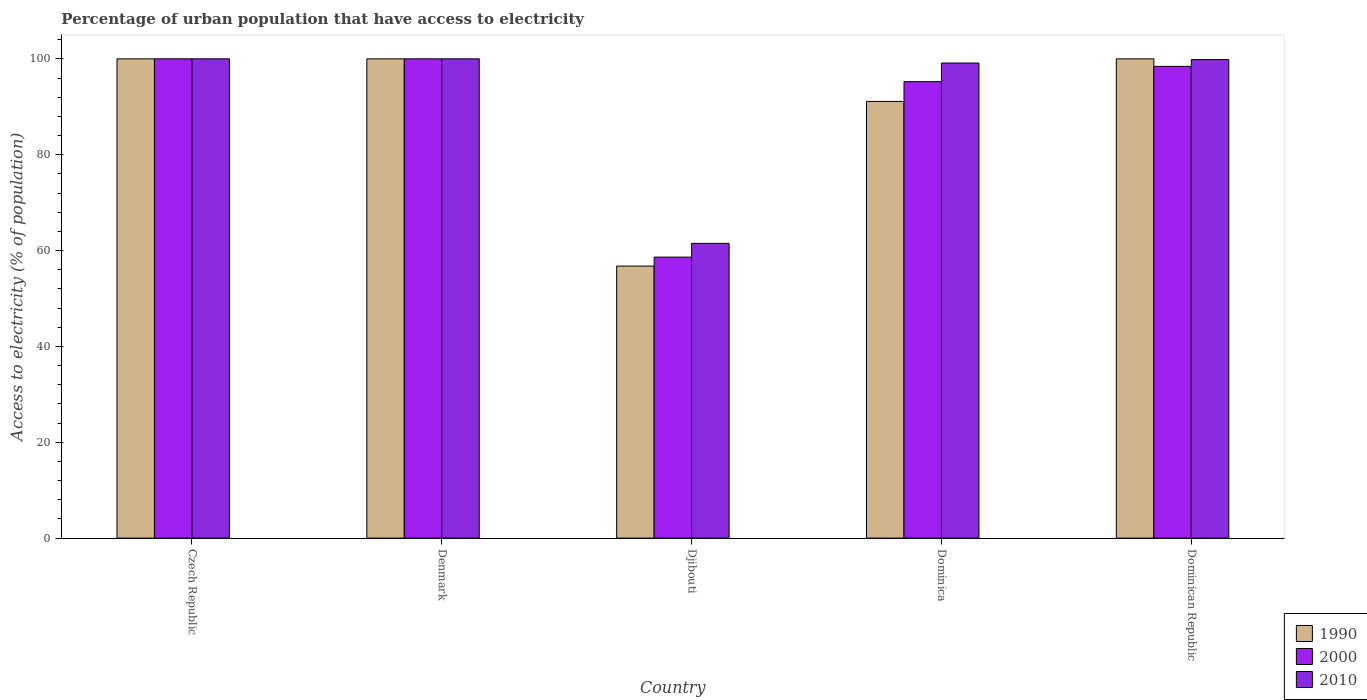How many groups of bars are there?
Provide a short and direct response. 5. Are the number of bars per tick equal to the number of legend labels?
Ensure brevity in your answer.  Yes. Are the number of bars on each tick of the X-axis equal?
Offer a very short reply. Yes. How many bars are there on the 5th tick from the left?
Provide a short and direct response. 3. What is the label of the 1st group of bars from the left?
Provide a succinct answer. Czech Republic. In how many cases, is the number of bars for a given country not equal to the number of legend labels?
Ensure brevity in your answer.  0. Across all countries, what is the minimum percentage of urban population that have access to electricity in 2000?
Offer a very short reply. 58.63. In which country was the percentage of urban population that have access to electricity in 2010 maximum?
Your response must be concise. Czech Republic. In which country was the percentage of urban population that have access to electricity in 1990 minimum?
Give a very brief answer. Djibouti. What is the total percentage of urban population that have access to electricity in 1990 in the graph?
Your response must be concise. 447.87. What is the difference between the percentage of urban population that have access to electricity in 1990 in Denmark and that in Dominica?
Keep it short and to the point. 8.88. What is the difference between the percentage of urban population that have access to electricity in 2000 in Czech Republic and the percentage of urban population that have access to electricity in 1990 in Denmark?
Your answer should be compact. 0. What is the average percentage of urban population that have access to electricity in 2000 per country?
Your answer should be compact. 90.46. What is the difference between the percentage of urban population that have access to electricity of/in 1990 and percentage of urban population that have access to electricity of/in 2010 in Djibouti?
Offer a very short reply. -4.74. In how many countries, is the percentage of urban population that have access to electricity in 2000 greater than 60 %?
Give a very brief answer. 4. What is the ratio of the percentage of urban population that have access to electricity in 1990 in Dominica to that in Dominican Republic?
Your answer should be compact. 0.91. Is the percentage of urban population that have access to electricity in 2010 in Czech Republic less than that in Denmark?
Your response must be concise. No. Is the difference between the percentage of urban population that have access to electricity in 1990 in Djibouti and Dominica greater than the difference between the percentage of urban population that have access to electricity in 2010 in Djibouti and Dominica?
Your response must be concise. Yes. What is the difference between the highest and the second highest percentage of urban population that have access to electricity in 2000?
Keep it short and to the point. -1.57. What is the difference between the highest and the lowest percentage of urban population that have access to electricity in 1990?
Your answer should be compact. 43.24. In how many countries, is the percentage of urban population that have access to electricity in 2010 greater than the average percentage of urban population that have access to electricity in 2010 taken over all countries?
Make the answer very short. 4. Are all the bars in the graph horizontal?
Offer a very short reply. No. What is the difference between two consecutive major ticks on the Y-axis?
Provide a short and direct response. 20. Does the graph contain any zero values?
Provide a short and direct response. No. Does the graph contain grids?
Your answer should be very brief. No. Where does the legend appear in the graph?
Keep it short and to the point. Bottom right. How many legend labels are there?
Offer a very short reply. 3. How are the legend labels stacked?
Make the answer very short. Vertical. What is the title of the graph?
Provide a short and direct response. Percentage of urban population that have access to electricity. What is the label or title of the Y-axis?
Offer a very short reply. Access to electricity (% of population). What is the Access to electricity (% of population) of 1990 in Czech Republic?
Your response must be concise. 100. What is the Access to electricity (% of population) in 1990 in Denmark?
Offer a terse response. 100. What is the Access to electricity (% of population) of 1990 in Djibouti?
Your response must be concise. 56.76. What is the Access to electricity (% of population) of 2000 in Djibouti?
Keep it short and to the point. 58.63. What is the Access to electricity (% of population) of 2010 in Djibouti?
Your answer should be compact. 61.5. What is the Access to electricity (% of population) of 1990 in Dominica?
Offer a terse response. 91.12. What is the Access to electricity (% of population) of 2000 in Dominica?
Provide a short and direct response. 95.24. What is the Access to electricity (% of population) of 2010 in Dominica?
Ensure brevity in your answer.  99.13. What is the Access to electricity (% of population) of 1990 in Dominican Republic?
Your response must be concise. 100. What is the Access to electricity (% of population) in 2000 in Dominican Republic?
Ensure brevity in your answer.  98.43. What is the Access to electricity (% of population) in 2010 in Dominican Republic?
Give a very brief answer. 99.84. Across all countries, what is the maximum Access to electricity (% of population) of 1990?
Ensure brevity in your answer.  100. Across all countries, what is the maximum Access to electricity (% of population) in 2000?
Provide a short and direct response. 100. Across all countries, what is the minimum Access to electricity (% of population) in 1990?
Make the answer very short. 56.76. Across all countries, what is the minimum Access to electricity (% of population) of 2000?
Keep it short and to the point. 58.63. Across all countries, what is the minimum Access to electricity (% of population) in 2010?
Make the answer very short. 61.5. What is the total Access to electricity (% of population) in 1990 in the graph?
Your answer should be very brief. 447.87. What is the total Access to electricity (% of population) of 2000 in the graph?
Your answer should be very brief. 452.3. What is the total Access to electricity (% of population) of 2010 in the graph?
Your answer should be very brief. 460.46. What is the difference between the Access to electricity (% of population) in 1990 in Czech Republic and that in Denmark?
Offer a very short reply. 0. What is the difference between the Access to electricity (% of population) of 2000 in Czech Republic and that in Denmark?
Give a very brief answer. 0. What is the difference between the Access to electricity (% of population) of 2010 in Czech Republic and that in Denmark?
Provide a succinct answer. 0. What is the difference between the Access to electricity (% of population) in 1990 in Czech Republic and that in Djibouti?
Provide a short and direct response. 43.24. What is the difference between the Access to electricity (% of population) of 2000 in Czech Republic and that in Djibouti?
Give a very brief answer. 41.37. What is the difference between the Access to electricity (% of population) of 2010 in Czech Republic and that in Djibouti?
Offer a terse response. 38.5. What is the difference between the Access to electricity (% of population) in 1990 in Czech Republic and that in Dominica?
Your answer should be very brief. 8.88. What is the difference between the Access to electricity (% of population) of 2000 in Czech Republic and that in Dominica?
Offer a terse response. 4.76. What is the difference between the Access to electricity (% of population) in 2010 in Czech Republic and that in Dominica?
Offer a very short reply. 0.87. What is the difference between the Access to electricity (% of population) in 2000 in Czech Republic and that in Dominican Republic?
Keep it short and to the point. 1.57. What is the difference between the Access to electricity (% of population) in 2010 in Czech Republic and that in Dominican Republic?
Offer a very short reply. 0.16. What is the difference between the Access to electricity (% of population) in 1990 in Denmark and that in Djibouti?
Your response must be concise. 43.24. What is the difference between the Access to electricity (% of population) of 2000 in Denmark and that in Djibouti?
Your answer should be very brief. 41.37. What is the difference between the Access to electricity (% of population) in 2010 in Denmark and that in Djibouti?
Give a very brief answer. 38.5. What is the difference between the Access to electricity (% of population) of 1990 in Denmark and that in Dominica?
Provide a succinct answer. 8.88. What is the difference between the Access to electricity (% of population) of 2000 in Denmark and that in Dominica?
Give a very brief answer. 4.76. What is the difference between the Access to electricity (% of population) in 2010 in Denmark and that in Dominica?
Ensure brevity in your answer.  0.87. What is the difference between the Access to electricity (% of population) of 2000 in Denmark and that in Dominican Republic?
Offer a very short reply. 1.57. What is the difference between the Access to electricity (% of population) in 2010 in Denmark and that in Dominican Republic?
Your response must be concise. 0.16. What is the difference between the Access to electricity (% of population) in 1990 in Djibouti and that in Dominica?
Keep it short and to the point. -34.36. What is the difference between the Access to electricity (% of population) of 2000 in Djibouti and that in Dominica?
Give a very brief answer. -36.61. What is the difference between the Access to electricity (% of population) of 2010 in Djibouti and that in Dominica?
Ensure brevity in your answer.  -37.63. What is the difference between the Access to electricity (% of population) in 1990 in Djibouti and that in Dominican Republic?
Give a very brief answer. -43.24. What is the difference between the Access to electricity (% of population) of 2000 in Djibouti and that in Dominican Republic?
Make the answer very short. -39.8. What is the difference between the Access to electricity (% of population) of 2010 in Djibouti and that in Dominican Republic?
Your response must be concise. -38.34. What is the difference between the Access to electricity (% of population) of 1990 in Dominica and that in Dominican Republic?
Provide a succinct answer. -8.88. What is the difference between the Access to electricity (% of population) of 2000 in Dominica and that in Dominican Republic?
Provide a short and direct response. -3.18. What is the difference between the Access to electricity (% of population) of 2010 in Dominica and that in Dominican Republic?
Offer a very short reply. -0.71. What is the difference between the Access to electricity (% of population) of 2000 in Czech Republic and the Access to electricity (% of population) of 2010 in Denmark?
Provide a succinct answer. 0. What is the difference between the Access to electricity (% of population) in 1990 in Czech Republic and the Access to electricity (% of population) in 2000 in Djibouti?
Provide a succinct answer. 41.37. What is the difference between the Access to electricity (% of population) of 1990 in Czech Republic and the Access to electricity (% of population) of 2010 in Djibouti?
Your answer should be very brief. 38.5. What is the difference between the Access to electricity (% of population) in 2000 in Czech Republic and the Access to electricity (% of population) in 2010 in Djibouti?
Your response must be concise. 38.5. What is the difference between the Access to electricity (% of population) in 1990 in Czech Republic and the Access to electricity (% of population) in 2000 in Dominica?
Give a very brief answer. 4.76. What is the difference between the Access to electricity (% of population) in 1990 in Czech Republic and the Access to electricity (% of population) in 2010 in Dominica?
Give a very brief answer. 0.87. What is the difference between the Access to electricity (% of population) of 2000 in Czech Republic and the Access to electricity (% of population) of 2010 in Dominica?
Ensure brevity in your answer.  0.87. What is the difference between the Access to electricity (% of population) of 1990 in Czech Republic and the Access to electricity (% of population) of 2000 in Dominican Republic?
Make the answer very short. 1.57. What is the difference between the Access to electricity (% of population) in 1990 in Czech Republic and the Access to electricity (% of population) in 2010 in Dominican Republic?
Your answer should be compact. 0.16. What is the difference between the Access to electricity (% of population) in 2000 in Czech Republic and the Access to electricity (% of population) in 2010 in Dominican Republic?
Ensure brevity in your answer.  0.16. What is the difference between the Access to electricity (% of population) in 1990 in Denmark and the Access to electricity (% of population) in 2000 in Djibouti?
Give a very brief answer. 41.37. What is the difference between the Access to electricity (% of population) in 1990 in Denmark and the Access to electricity (% of population) in 2010 in Djibouti?
Provide a short and direct response. 38.5. What is the difference between the Access to electricity (% of population) of 2000 in Denmark and the Access to electricity (% of population) of 2010 in Djibouti?
Offer a very short reply. 38.5. What is the difference between the Access to electricity (% of population) in 1990 in Denmark and the Access to electricity (% of population) in 2000 in Dominica?
Your answer should be compact. 4.76. What is the difference between the Access to electricity (% of population) of 1990 in Denmark and the Access to electricity (% of population) of 2010 in Dominica?
Give a very brief answer. 0.87. What is the difference between the Access to electricity (% of population) in 2000 in Denmark and the Access to electricity (% of population) in 2010 in Dominica?
Your answer should be compact. 0.87. What is the difference between the Access to electricity (% of population) in 1990 in Denmark and the Access to electricity (% of population) in 2000 in Dominican Republic?
Your answer should be compact. 1.57. What is the difference between the Access to electricity (% of population) of 1990 in Denmark and the Access to electricity (% of population) of 2010 in Dominican Republic?
Your answer should be compact. 0.16. What is the difference between the Access to electricity (% of population) of 2000 in Denmark and the Access to electricity (% of population) of 2010 in Dominican Republic?
Offer a very short reply. 0.16. What is the difference between the Access to electricity (% of population) of 1990 in Djibouti and the Access to electricity (% of population) of 2000 in Dominica?
Make the answer very short. -38.49. What is the difference between the Access to electricity (% of population) of 1990 in Djibouti and the Access to electricity (% of population) of 2010 in Dominica?
Keep it short and to the point. -42.37. What is the difference between the Access to electricity (% of population) of 2000 in Djibouti and the Access to electricity (% of population) of 2010 in Dominica?
Make the answer very short. -40.5. What is the difference between the Access to electricity (% of population) of 1990 in Djibouti and the Access to electricity (% of population) of 2000 in Dominican Republic?
Make the answer very short. -41.67. What is the difference between the Access to electricity (% of population) of 1990 in Djibouti and the Access to electricity (% of population) of 2010 in Dominican Republic?
Give a very brief answer. -43.08. What is the difference between the Access to electricity (% of population) in 2000 in Djibouti and the Access to electricity (% of population) in 2010 in Dominican Republic?
Ensure brevity in your answer.  -41.21. What is the difference between the Access to electricity (% of population) of 1990 in Dominica and the Access to electricity (% of population) of 2000 in Dominican Republic?
Keep it short and to the point. -7.31. What is the difference between the Access to electricity (% of population) of 1990 in Dominica and the Access to electricity (% of population) of 2010 in Dominican Republic?
Ensure brevity in your answer.  -8.72. What is the difference between the Access to electricity (% of population) in 2000 in Dominica and the Access to electricity (% of population) in 2010 in Dominican Republic?
Keep it short and to the point. -4.59. What is the average Access to electricity (% of population) in 1990 per country?
Your answer should be compact. 89.57. What is the average Access to electricity (% of population) of 2000 per country?
Ensure brevity in your answer.  90.46. What is the average Access to electricity (% of population) in 2010 per country?
Your response must be concise. 92.09. What is the difference between the Access to electricity (% of population) of 2000 and Access to electricity (% of population) of 2010 in Czech Republic?
Give a very brief answer. 0. What is the difference between the Access to electricity (% of population) of 1990 and Access to electricity (% of population) of 2010 in Denmark?
Offer a very short reply. 0. What is the difference between the Access to electricity (% of population) in 2000 and Access to electricity (% of population) in 2010 in Denmark?
Give a very brief answer. 0. What is the difference between the Access to electricity (% of population) of 1990 and Access to electricity (% of population) of 2000 in Djibouti?
Provide a succinct answer. -1.87. What is the difference between the Access to electricity (% of population) in 1990 and Access to electricity (% of population) in 2010 in Djibouti?
Give a very brief answer. -4.74. What is the difference between the Access to electricity (% of population) of 2000 and Access to electricity (% of population) of 2010 in Djibouti?
Provide a short and direct response. -2.87. What is the difference between the Access to electricity (% of population) of 1990 and Access to electricity (% of population) of 2000 in Dominica?
Provide a short and direct response. -4.12. What is the difference between the Access to electricity (% of population) in 1990 and Access to electricity (% of population) in 2010 in Dominica?
Provide a succinct answer. -8.01. What is the difference between the Access to electricity (% of population) of 2000 and Access to electricity (% of population) of 2010 in Dominica?
Provide a succinct answer. -3.89. What is the difference between the Access to electricity (% of population) in 1990 and Access to electricity (% of population) in 2000 in Dominican Republic?
Your response must be concise. 1.57. What is the difference between the Access to electricity (% of population) in 1990 and Access to electricity (% of population) in 2010 in Dominican Republic?
Offer a terse response. 0.16. What is the difference between the Access to electricity (% of population) in 2000 and Access to electricity (% of population) in 2010 in Dominican Republic?
Give a very brief answer. -1.41. What is the ratio of the Access to electricity (% of population) in 1990 in Czech Republic to that in Djibouti?
Your answer should be very brief. 1.76. What is the ratio of the Access to electricity (% of population) of 2000 in Czech Republic to that in Djibouti?
Offer a very short reply. 1.71. What is the ratio of the Access to electricity (% of population) in 2010 in Czech Republic to that in Djibouti?
Offer a terse response. 1.63. What is the ratio of the Access to electricity (% of population) of 1990 in Czech Republic to that in Dominica?
Ensure brevity in your answer.  1.1. What is the ratio of the Access to electricity (% of population) of 2010 in Czech Republic to that in Dominica?
Ensure brevity in your answer.  1.01. What is the ratio of the Access to electricity (% of population) in 2000 in Czech Republic to that in Dominican Republic?
Make the answer very short. 1.02. What is the ratio of the Access to electricity (% of population) in 1990 in Denmark to that in Djibouti?
Offer a terse response. 1.76. What is the ratio of the Access to electricity (% of population) in 2000 in Denmark to that in Djibouti?
Your response must be concise. 1.71. What is the ratio of the Access to electricity (% of population) in 2010 in Denmark to that in Djibouti?
Make the answer very short. 1.63. What is the ratio of the Access to electricity (% of population) in 1990 in Denmark to that in Dominica?
Your response must be concise. 1.1. What is the ratio of the Access to electricity (% of population) in 2010 in Denmark to that in Dominica?
Provide a short and direct response. 1.01. What is the ratio of the Access to electricity (% of population) of 2010 in Denmark to that in Dominican Republic?
Provide a short and direct response. 1. What is the ratio of the Access to electricity (% of population) of 1990 in Djibouti to that in Dominica?
Your response must be concise. 0.62. What is the ratio of the Access to electricity (% of population) of 2000 in Djibouti to that in Dominica?
Offer a very short reply. 0.62. What is the ratio of the Access to electricity (% of population) in 2010 in Djibouti to that in Dominica?
Ensure brevity in your answer.  0.62. What is the ratio of the Access to electricity (% of population) in 1990 in Djibouti to that in Dominican Republic?
Provide a short and direct response. 0.57. What is the ratio of the Access to electricity (% of population) in 2000 in Djibouti to that in Dominican Republic?
Offer a terse response. 0.6. What is the ratio of the Access to electricity (% of population) of 2010 in Djibouti to that in Dominican Republic?
Make the answer very short. 0.62. What is the ratio of the Access to electricity (% of population) in 1990 in Dominica to that in Dominican Republic?
Ensure brevity in your answer.  0.91. What is the ratio of the Access to electricity (% of population) in 2000 in Dominica to that in Dominican Republic?
Your response must be concise. 0.97. What is the difference between the highest and the second highest Access to electricity (% of population) in 2010?
Keep it short and to the point. 0. What is the difference between the highest and the lowest Access to electricity (% of population) in 1990?
Your response must be concise. 43.24. What is the difference between the highest and the lowest Access to electricity (% of population) in 2000?
Offer a terse response. 41.37. What is the difference between the highest and the lowest Access to electricity (% of population) of 2010?
Offer a very short reply. 38.5. 